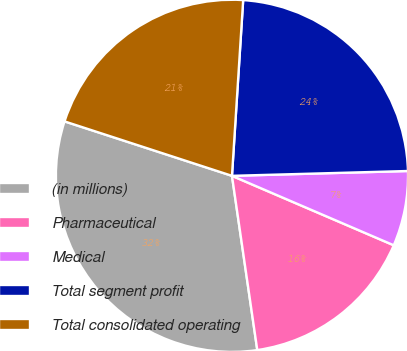Convert chart to OTSL. <chart><loc_0><loc_0><loc_500><loc_500><pie_chart><fcel>(in millions)<fcel>Pharmaceutical<fcel>Medical<fcel>Total segment profit<fcel>Total consolidated operating<nl><fcel>32.3%<fcel>16.25%<fcel>6.89%<fcel>23.55%<fcel>21.01%<nl></chart> 